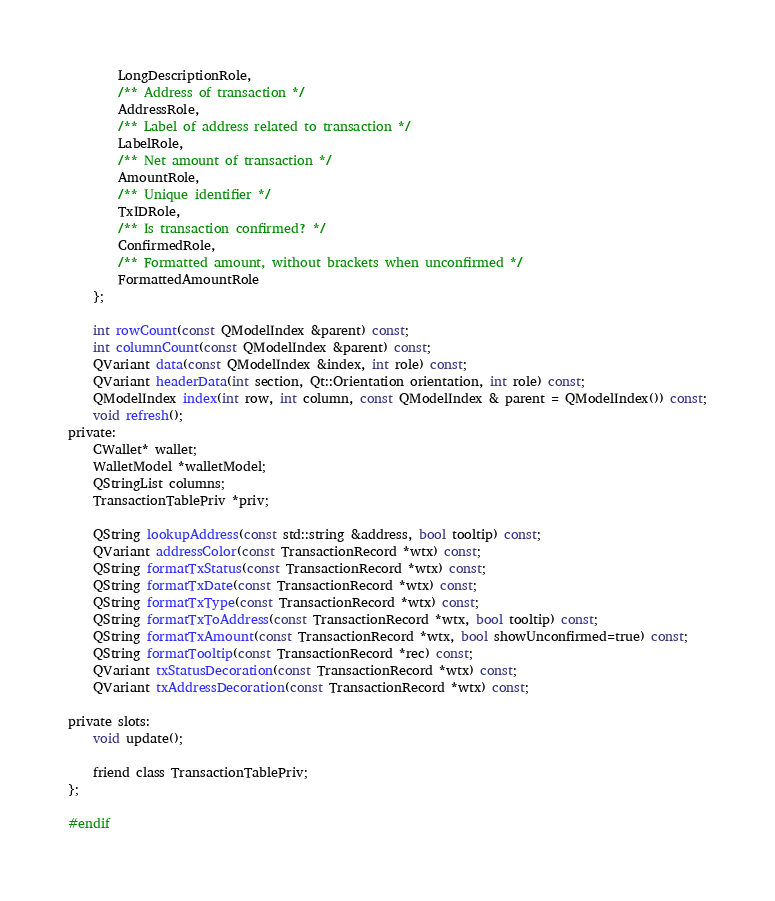<code> <loc_0><loc_0><loc_500><loc_500><_C_>        LongDescriptionRole,
        /** Address of transaction */
        AddressRole,
        /** Label of address related to transaction */
        LabelRole,
        /** Net amount of transaction */
        AmountRole,
        /** Unique identifier */
        TxIDRole,
        /** Is transaction confirmed? */
        ConfirmedRole,
        /** Formatted amount, without brackets when unconfirmed */
        FormattedAmountRole
    };

    int rowCount(const QModelIndex &parent) const;
    int columnCount(const QModelIndex &parent) const;
    QVariant data(const QModelIndex &index, int role) const;
    QVariant headerData(int section, Qt::Orientation orientation, int role) const;
    QModelIndex index(int row, int column, const QModelIndex & parent = QModelIndex()) const;
    void refresh();
private:
    CWallet* wallet;
    WalletModel *walletModel;
    QStringList columns;
    TransactionTablePriv *priv;

    QString lookupAddress(const std::string &address, bool tooltip) const;
    QVariant addressColor(const TransactionRecord *wtx) const;
    QString formatTxStatus(const TransactionRecord *wtx) const;
    QString formatTxDate(const TransactionRecord *wtx) const;
    QString formatTxType(const TransactionRecord *wtx) const;
    QString formatTxToAddress(const TransactionRecord *wtx, bool tooltip) const;
    QString formatTxAmount(const TransactionRecord *wtx, bool showUnconfirmed=true) const;
    QString formatTooltip(const TransactionRecord *rec) const;
    QVariant txStatusDecoration(const TransactionRecord *wtx) const;
    QVariant txAddressDecoration(const TransactionRecord *wtx) const;

private slots:
    void update();

    friend class TransactionTablePriv;
};

#endif

</code> 